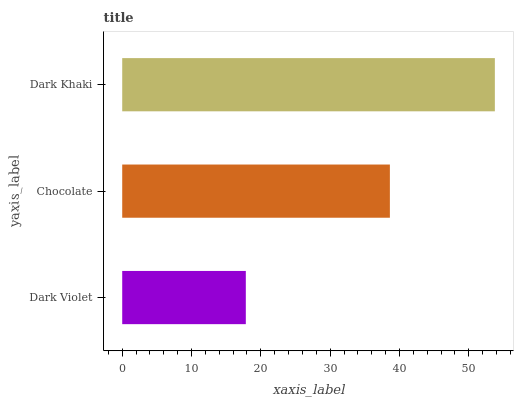Is Dark Violet the minimum?
Answer yes or no. Yes. Is Dark Khaki the maximum?
Answer yes or no. Yes. Is Chocolate the minimum?
Answer yes or no. No. Is Chocolate the maximum?
Answer yes or no. No. Is Chocolate greater than Dark Violet?
Answer yes or no. Yes. Is Dark Violet less than Chocolate?
Answer yes or no. Yes. Is Dark Violet greater than Chocolate?
Answer yes or no. No. Is Chocolate less than Dark Violet?
Answer yes or no. No. Is Chocolate the high median?
Answer yes or no. Yes. Is Chocolate the low median?
Answer yes or no. Yes. Is Dark Khaki the high median?
Answer yes or no. No. Is Dark Khaki the low median?
Answer yes or no. No. 